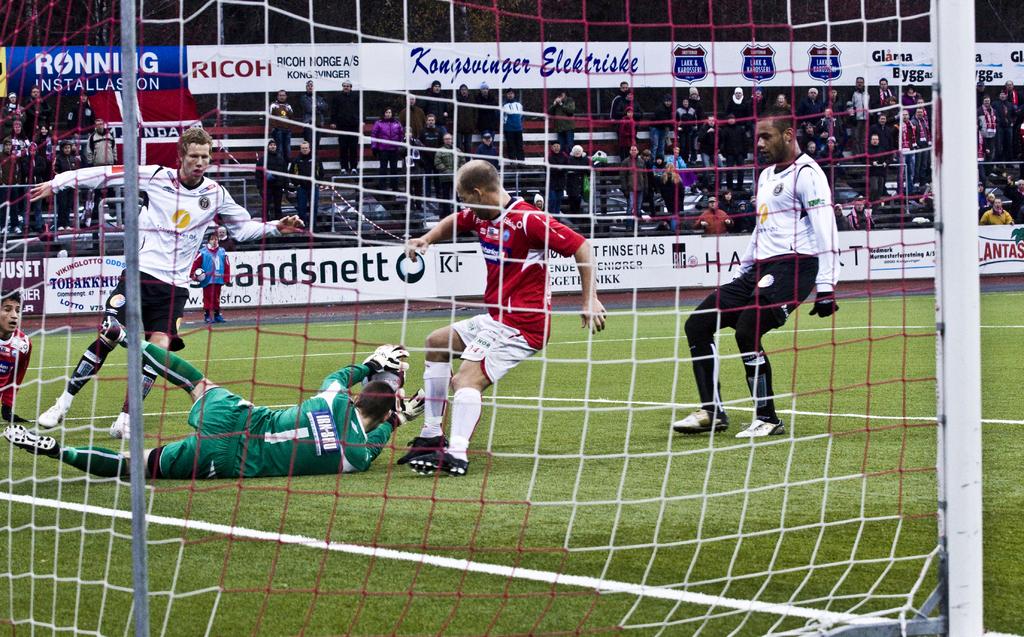What is the number on the green jersey?
Provide a short and direct response. 1. What number is the player in green?
Your response must be concise. 1. 